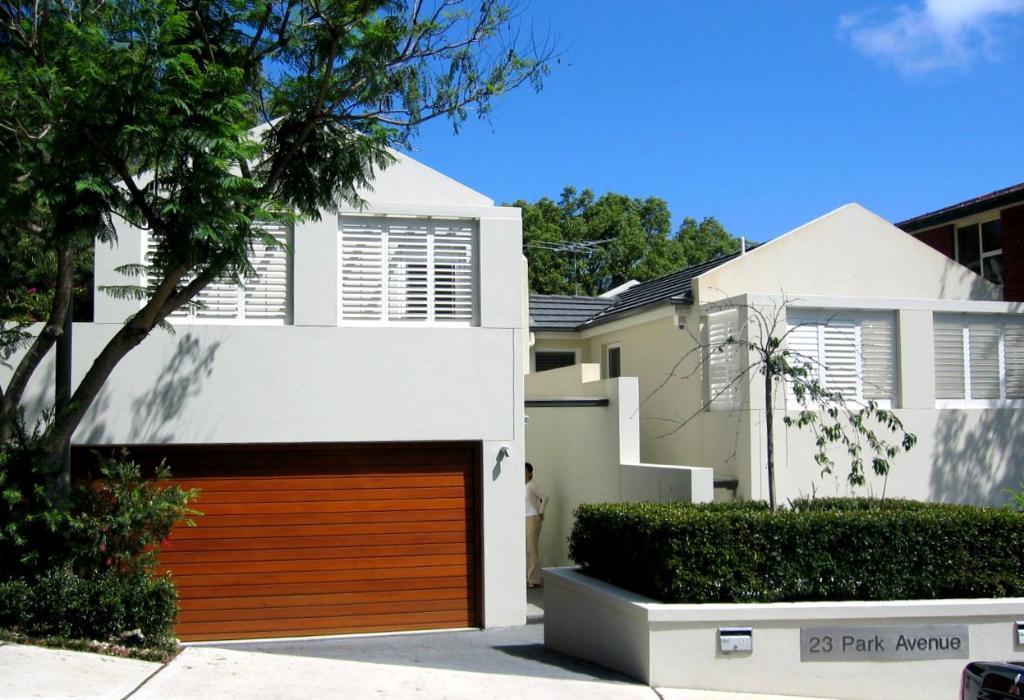How would you summarize this image in a sentence or two? In this picture we can see few buildings, trees, plants and clouds, in the middle of the image we can see a person. 